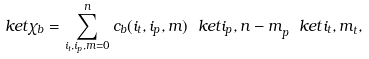<formula> <loc_0><loc_0><loc_500><loc_500>\ k e t { \chi _ { b } } = \sum _ { i _ { t } , i _ { p } , m = 0 } ^ { n } c _ { b } ( i _ { t } , i _ { p } , m ) \ k e t { i _ { p } , n - m } _ { p } \ k e t { i _ { t } , m } _ { t } ,</formula> 